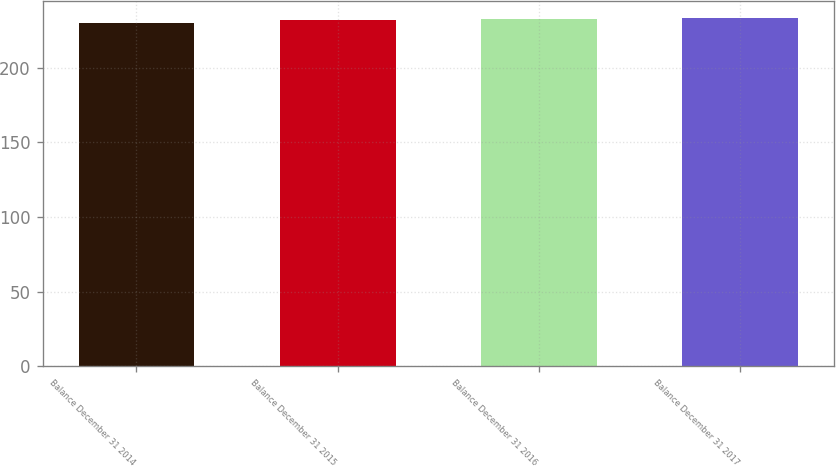<chart> <loc_0><loc_0><loc_500><loc_500><bar_chart><fcel>Balance December 31 2014<fcel>Balance December 31 2015<fcel>Balance December 31 2016<fcel>Balance December 31 2017<nl><fcel>230<fcel>232<fcel>232.3<fcel>233<nl></chart> 